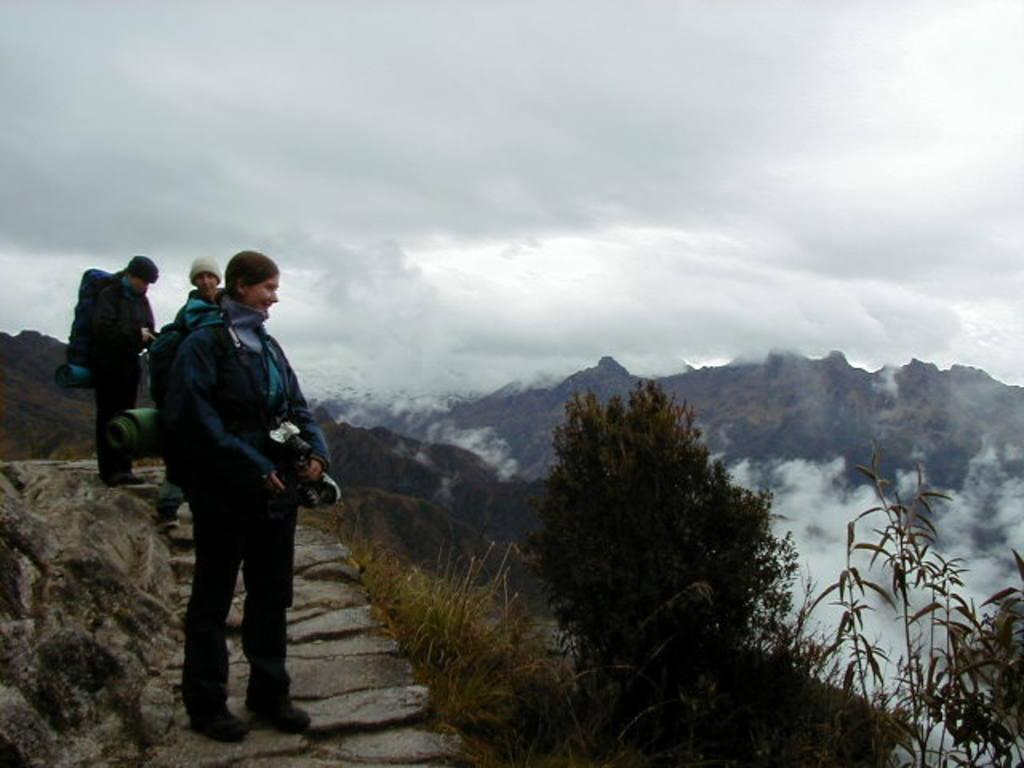How many people are in the image? There are three persons in the image. Where are the persons located in the image? The persons are on top of a hill. What can be seen on the right side of the image? There are plants on the right side of the image. What is visible in the background of the image? There are mountains and a cloudy sky in the background of the image. What type of crate is being attacked by the persons in the image? There is no crate present in the image, and no one is attacking anything. 